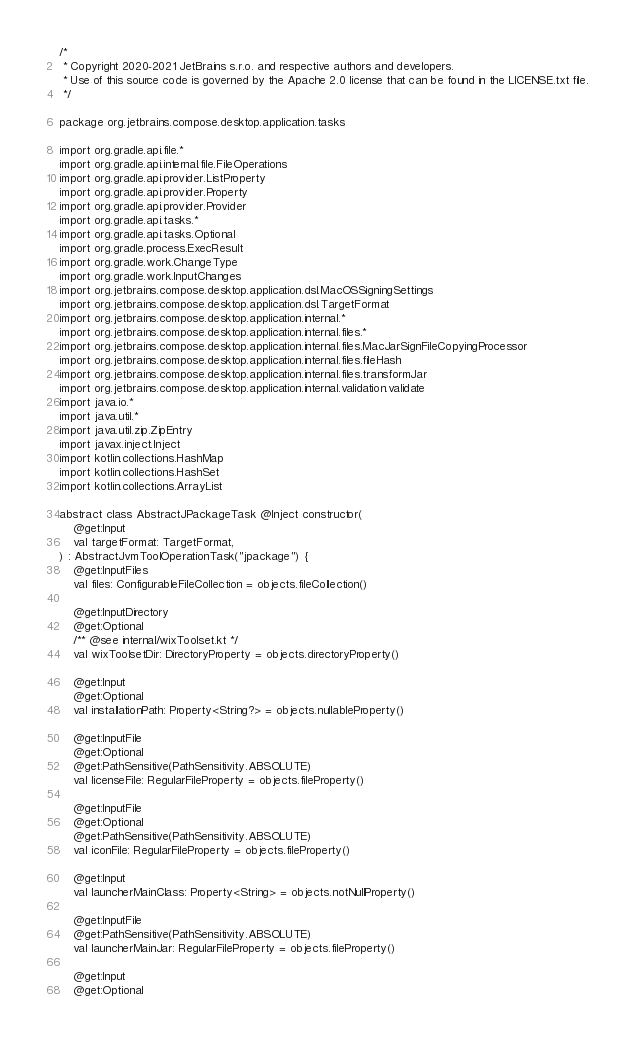Convert code to text. <code><loc_0><loc_0><loc_500><loc_500><_Kotlin_>/*
 * Copyright 2020-2021 JetBrains s.r.o. and respective authors and developers.
 * Use of this source code is governed by the Apache 2.0 license that can be found in the LICENSE.txt file.
 */

package org.jetbrains.compose.desktop.application.tasks

import org.gradle.api.file.*
import org.gradle.api.internal.file.FileOperations
import org.gradle.api.provider.ListProperty
import org.gradle.api.provider.Property
import org.gradle.api.provider.Provider
import org.gradle.api.tasks.*
import org.gradle.api.tasks.Optional
import org.gradle.process.ExecResult
import org.gradle.work.ChangeType
import org.gradle.work.InputChanges
import org.jetbrains.compose.desktop.application.dsl.MacOSSigningSettings
import org.jetbrains.compose.desktop.application.dsl.TargetFormat
import org.jetbrains.compose.desktop.application.internal.*
import org.jetbrains.compose.desktop.application.internal.files.*
import org.jetbrains.compose.desktop.application.internal.files.MacJarSignFileCopyingProcessor
import org.jetbrains.compose.desktop.application.internal.files.fileHash
import org.jetbrains.compose.desktop.application.internal.files.transformJar
import org.jetbrains.compose.desktop.application.internal.validation.validate
import java.io.*
import java.util.*
import java.util.zip.ZipEntry
import javax.inject.Inject
import kotlin.collections.HashMap
import kotlin.collections.HashSet
import kotlin.collections.ArrayList

abstract class AbstractJPackageTask @Inject constructor(
    @get:Input
    val targetFormat: TargetFormat,
) : AbstractJvmToolOperationTask("jpackage") {
    @get:InputFiles
    val files: ConfigurableFileCollection = objects.fileCollection()

    @get:InputDirectory
    @get:Optional
    /** @see internal/wixToolset.kt */
    val wixToolsetDir: DirectoryProperty = objects.directoryProperty()

    @get:Input
    @get:Optional
    val installationPath: Property<String?> = objects.nullableProperty()

    @get:InputFile
    @get:Optional
    @get:PathSensitive(PathSensitivity.ABSOLUTE)
    val licenseFile: RegularFileProperty = objects.fileProperty()

    @get:InputFile
    @get:Optional
    @get:PathSensitive(PathSensitivity.ABSOLUTE)
    val iconFile: RegularFileProperty = objects.fileProperty()

    @get:Input
    val launcherMainClass: Property<String> = objects.notNullProperty()

    @get:InputFile
    @get:PathSensitive(PathSensitivity.ABSOLUTE)
    val launcherMainJar: RegularFileProperty = objects.fileProperty()

    @get:Input
    @get:Optional</code> 